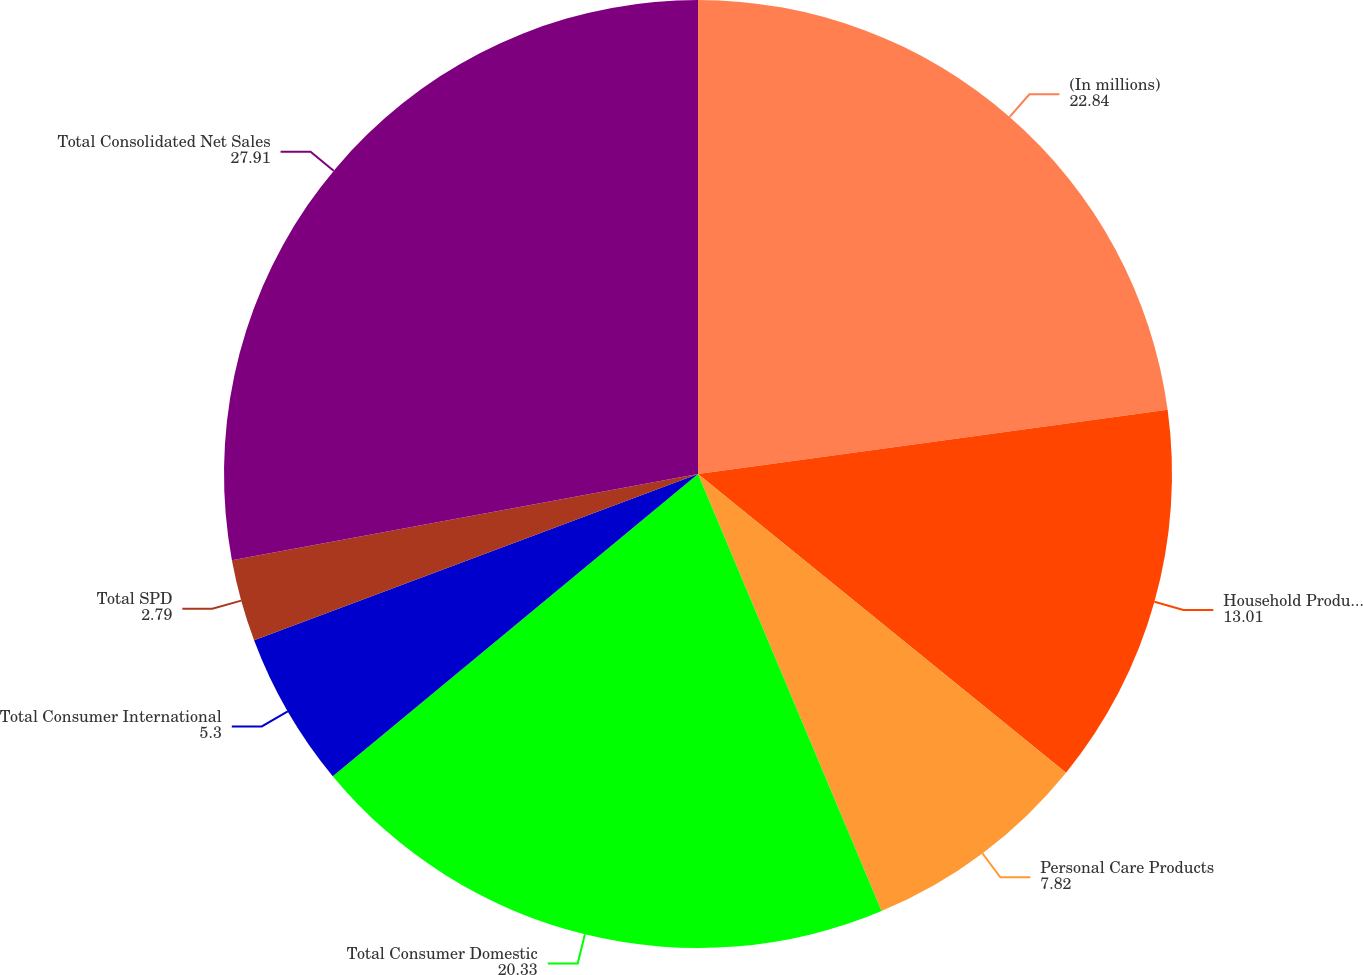<chart> <loc_0><loc_0><loc_500><loc_500><pie_chart><fcel>(In millions)<fcel>Household Products<fcel>Personal Care Products<fcel>Total Consumer Domestic<fcel>Total Consumer International<fcel>Total SPD<fcel>Total Consolidated Net Sales<nl><fcel>22.84%<fcel>13.01%<fcel>7.82%<fcel>20.33%<fcel>5.3%<fcel>2.79%<fcel>27.91%<nl></chart> 